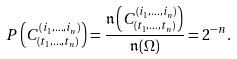<formula> <loc_0><loc_0><loc_500><loc_500>P \left ( C _ { \left ( t _ { 1 } , \dots , t _ { n } \right ) } ^ { \left ( i _ { 1 } , \dots , i _ { n } \right ) } \right ) = \frac { \mathfrak { n } \left ( C _ { \left ( t _ { 1 } , \dots , t _ { n } \right ) } ^ { \left ( i _ { 1 } , \dots , i _ { n } \right ) } \right ) } { \mathfrak { n } ( \Omega ) } = 2 ^ { - n } .</formula> 